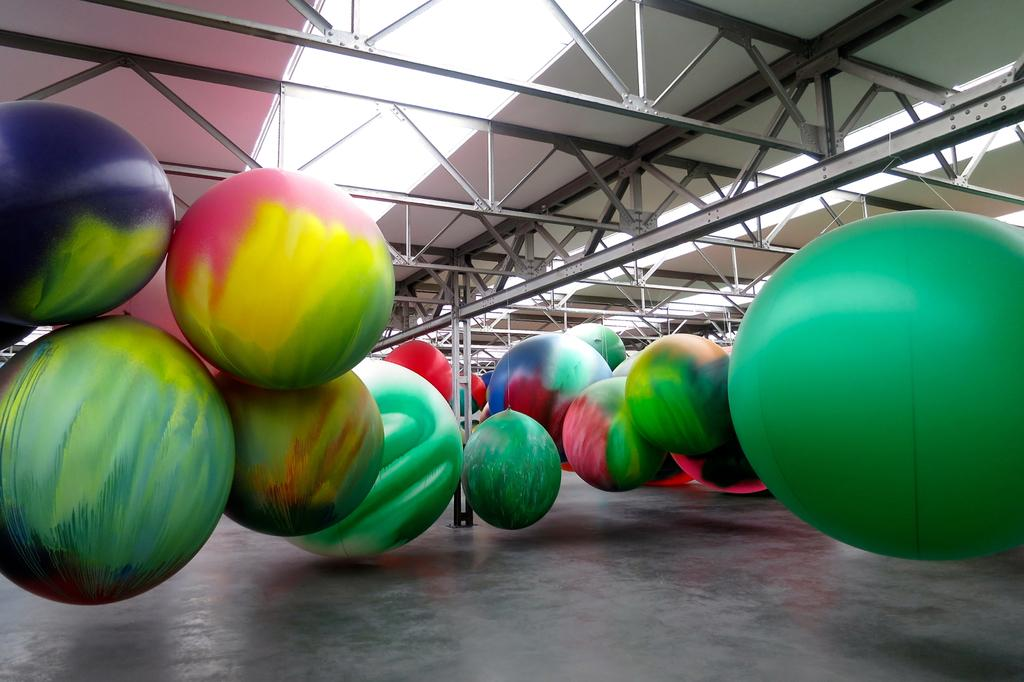What is located in the center of the image? There are balloons in the center of the image. What is the surface beneath the balloons? There is a floor at the bottom of the image. What is the structure above the balloons? There is a roof visible at the top of the image. What are the long, thin objects in the image? There are rods present in the image. What does the dad do to the balloons in the image? There is no dad present in the image, so it is not possible to answer that question. 